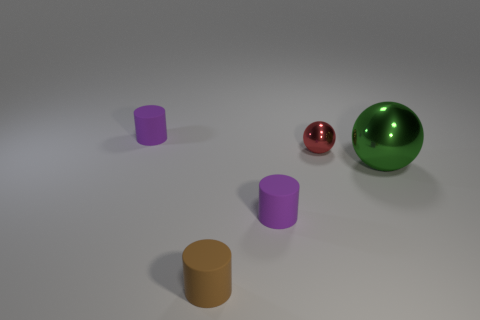Subtract all tiny purple cylinders. How many cylinders are left? 1 Subtract all brown cylinders. How many cylinders are left? 2 Subtract all spheres. How many objects are left? 3 Subtract 3 cylinders. How many cylinders are left? 0 Subtract all red spheres. Subtract all red cylinders. How many spheres are left? 1 Subtract all gray cylinders. How many blue balls are left? 0 Subtract all purple matte objects. Subtract all large green things. How many objects are left? 2 Add 4 small rubber cylinders. How many small rubber cylinders are left? 7 Add 2 big cyan matte cylinders. How many big cyan matte cylinders exist? 2 Add 4 small brown matte things. How many objects exist? 9 